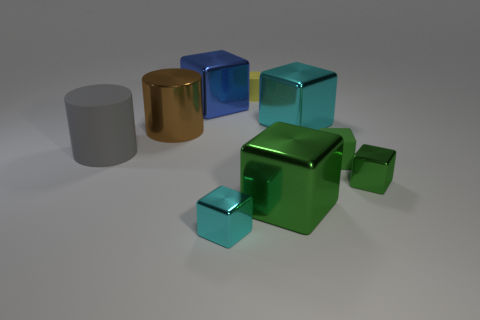How many green cubes must be subtracted to get 2 green cubes? 1 Subtract all yellow spheres. How many green blocks are left? 3 Subtract 3 cubes. How many cubes are left? 3 Subtract all cyan cubes. How many cubes are left? 4 Subtract all blue cubes. How many cubes are left? 5 Subtract all blue cubes. Subtract all green spheres. How many cubes are left? 5 Subtract all cylinders. How many objects are left? 6 Subtract 1 gray cylinders. How many objects are left? 8 Subtract all cubes. Subtract all big cyan shiny blocks. How many objects are left? 2 Add 6 tiny metallic blocks. How many tiny metallic blocks are left? 8 